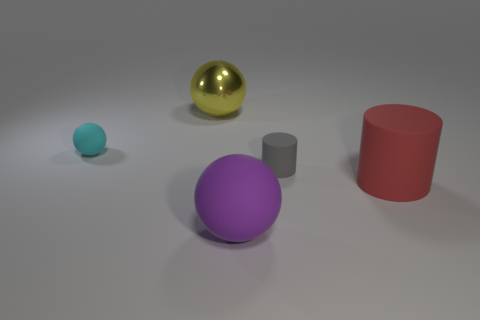Add 3 large green shiny balls. How many objects exist? 8 Subtract all cylinders. How many objects are left? 3 Add 1 small balls. How many small balls are left? 2 Add 3 large yellow rubber cubes. How many large yellow rubber cubes exist? 3 Subtract 0 cyan cylinders. How many objects are left? 5 Subtract all big rubber spheres. Subtract all large matte objects. How many objects are left? 2 